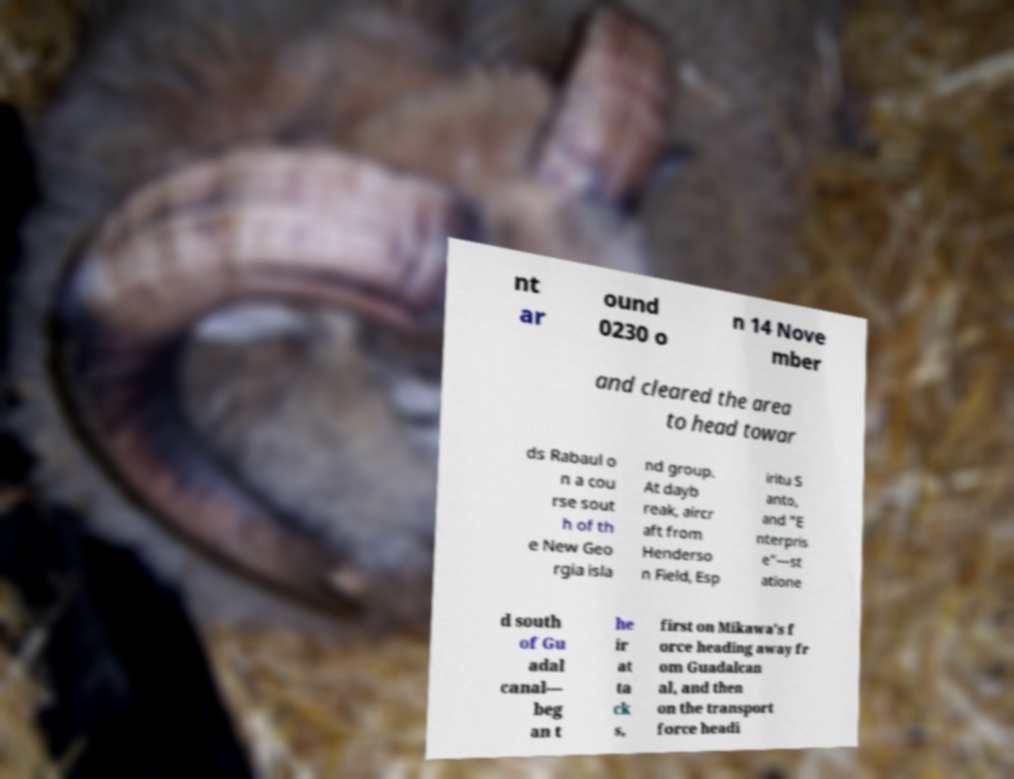Could you extract and type out the text from this image? nt ar ound 0230 o n 14 Nove mber and cleared the area to head towar ds Rabaul o n a cou rse sout h of th e New Geo rgia isla nd group. At dayb reak, aircr aft from Henderso n Field, Esp iritu S anto, and "E nterpris e"—st atione d south of Gu adal canal— beg an t he ir at ta ck s, first on Mikawa's f orce heading away fr om Guadalcan al, and then on the transport force headi 